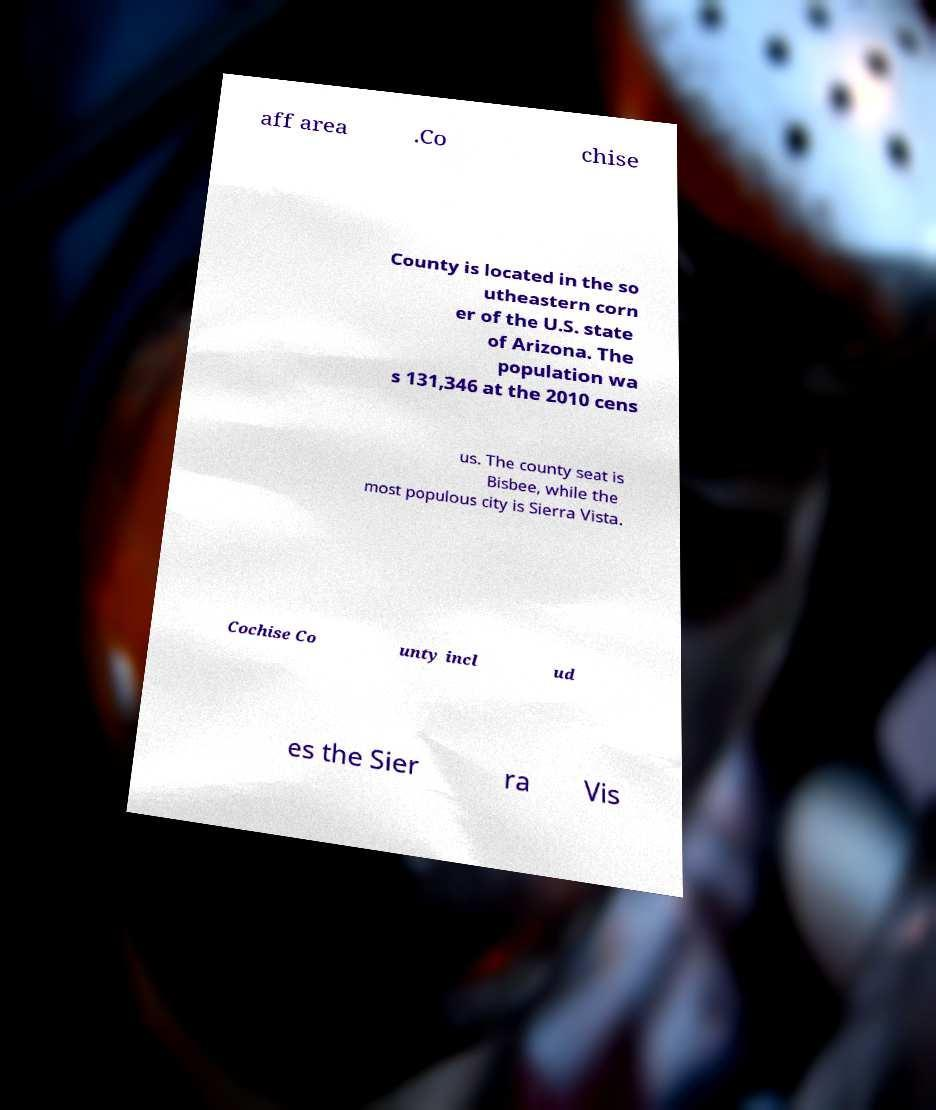There's text embedded in this image that I need extracted. Can you transcribe it verbatim? aff area .Co chise County is located in the so utheastern corn er of the U.S. state of Arizona. The population wa s 131,346 at the 2010 cens us. The county seat is Bisbee, while the most populous city is Sierra Vista. Cochise Co unty incl ud es the Sier ra Vis 